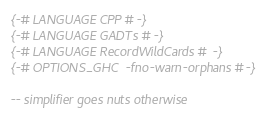Convert code to text. <code><loc_0><loc_0><loc_500><loc_500><_Haskell_>{-# LANGUAGE CPP #-}
{-# LANGUAGE GADTs #-}
{-# LANGUAGE RecordWildCards #-}
{-# OPTIONS_GHC -fno-warn-orphans #-}

-- simplifier goes nuts otherwise</code> 